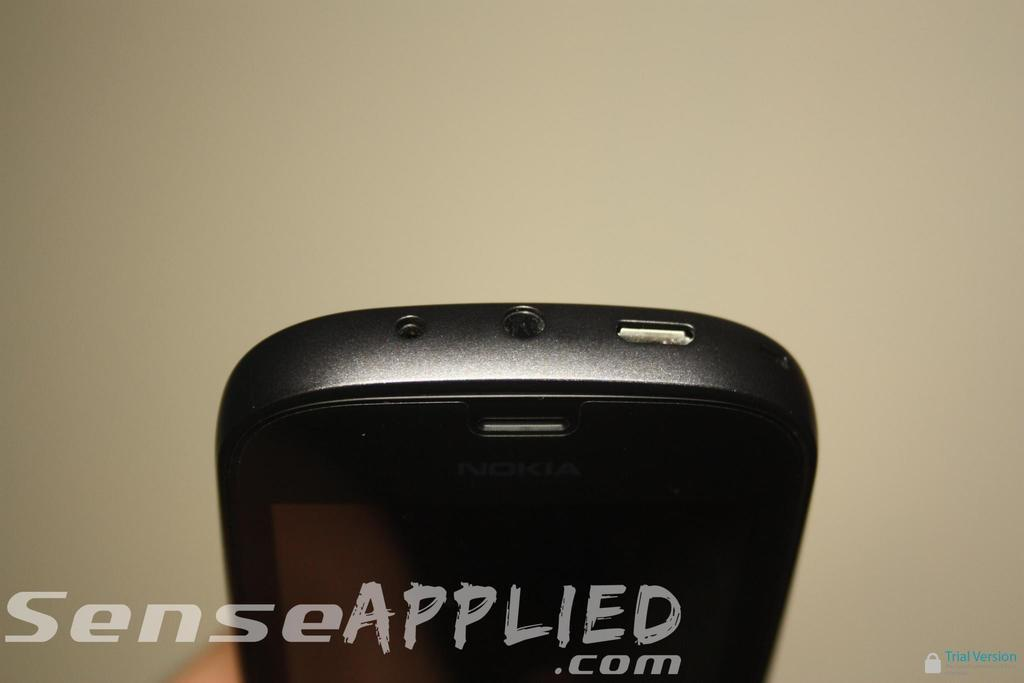<image>
Summarize the visual content of the image. the word applied is on the screen in front of some black items 